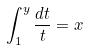<formula> <loc_0><loc_0><loc_500><loc_500>\int _ { 1 } ^ { y } \frac { d t } { t } = x</formula> 